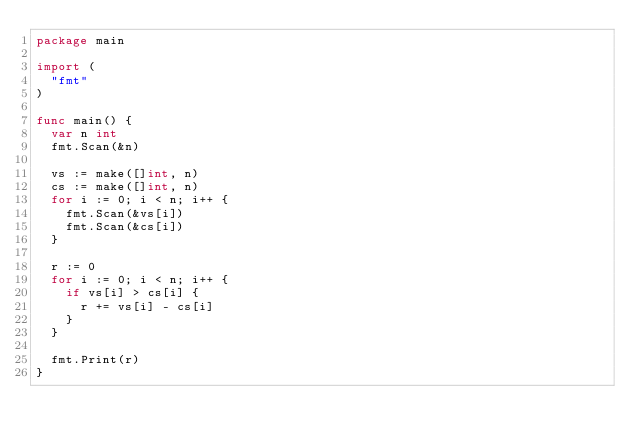Convert code to text. <code><loc_0><loc_0><loc_500><loc_500><_Go_>package main

import (
	"fmt"
)

func main() {
	var n int
	fmt.Scan(&n)

	vs := make([]int, n)
	cs := make([]int, n)
	for i := 0; i < n; i++ {
		fmt.Scan(&vs[i])
		fmt.Scan(&cs[i])
	}

	r := 0
	for i := 0; i < n; i++ {
		if vs[i] > cs[i] {
			r += vs[i] - cs[i]
		}
	}

	fmt.Print(r)
}
</code> 